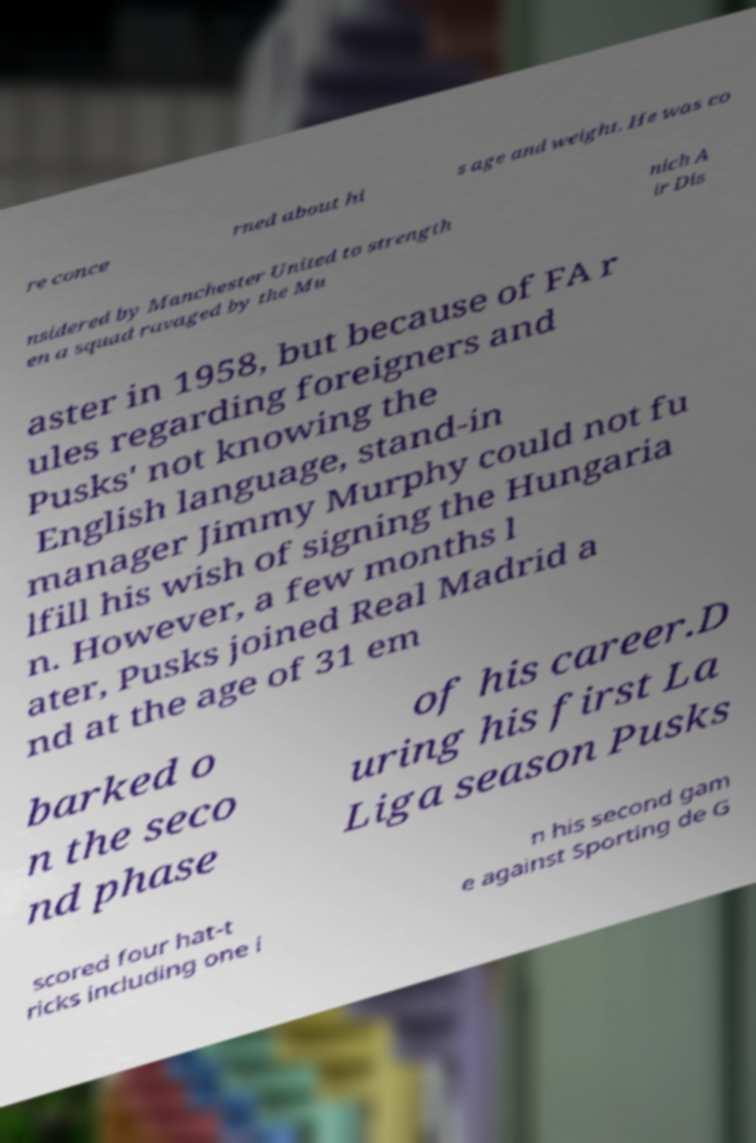Please read and relay the text visible in this image. What does it say? re conce rned about hi s age and weight. He was co nsidered by Manchester United to strength en a squad ravaged by the Mu nich A ir Dis aster in 1958, but because of FA r ules regarding foreigners and Pusks' not knowing the English language, stand-in manager Jimmy Murphy could not fu lfill his wish of signing the Hungaria n. However, a few months l ater, Pusks joined Real Madrid a nd at the age of 31 em barked o n the seco nd phase of his career.D uring his first La Liga season Pusks scored four hat-t ricks including one i n his second gam e against Sporting de G 